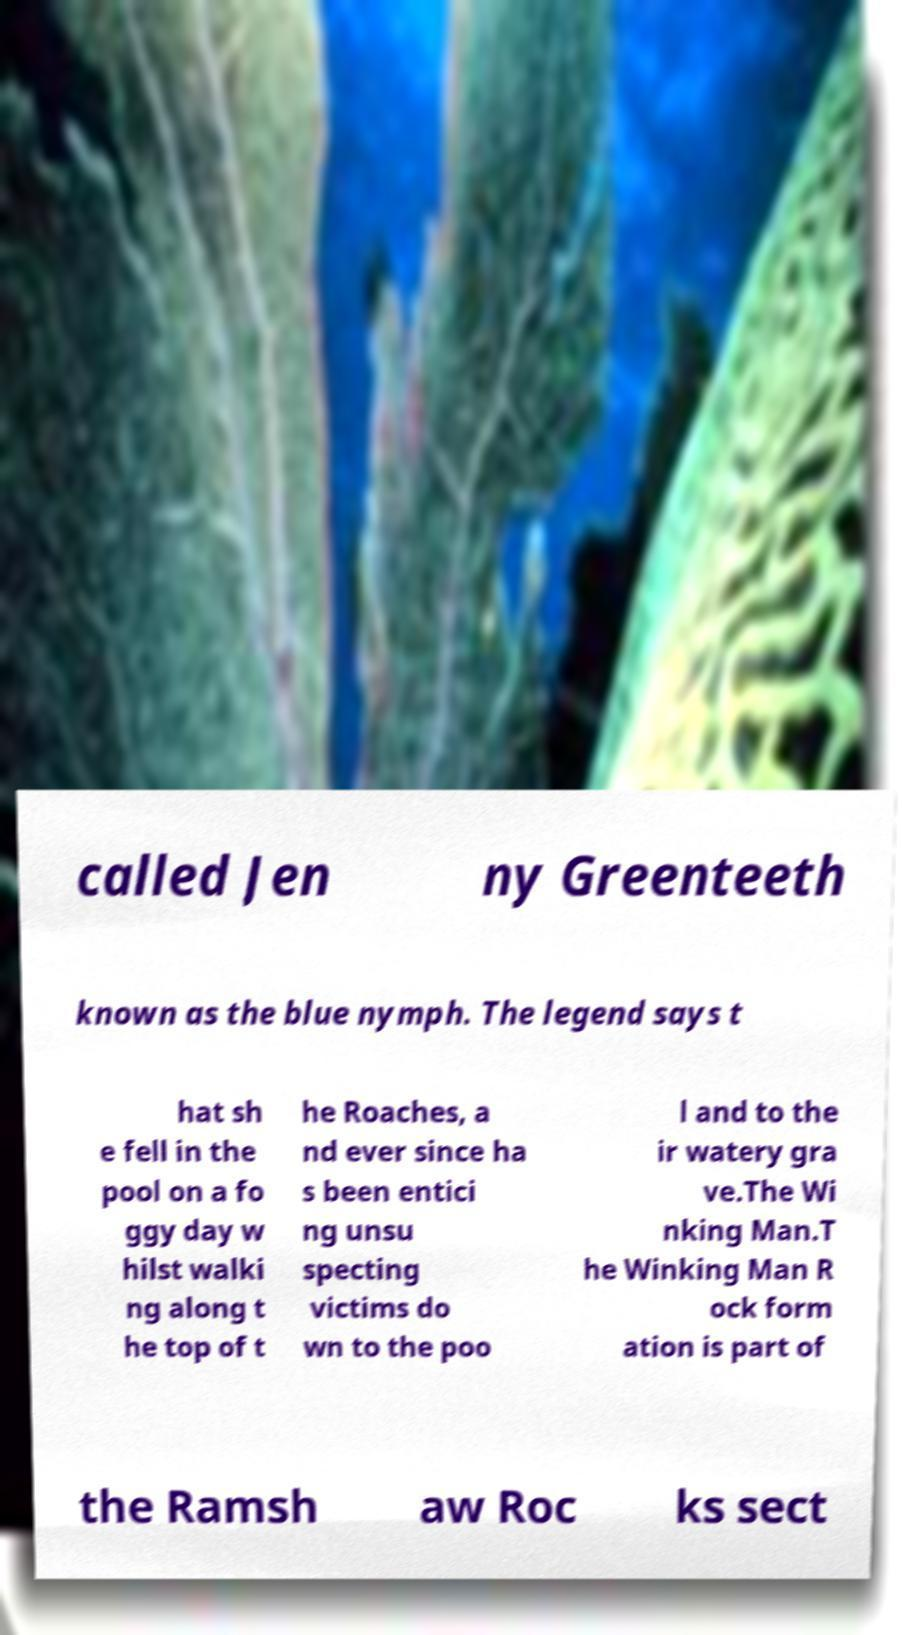Could you extract and type out the text from this image? called Jen ny Greenteeth known as the blue nymph. The legend says t hat sh e fell in the pool on a fo ggy day w hilst walki ng along t he top of t he Roaches, a nd ever since ha s been entici ng unsu specting victims do wn to the poo l and to the ir watery gra ve.The Wi nking Man.T he Winking Man R ock form ation is part of the Ramsh aw Roc ks sect 